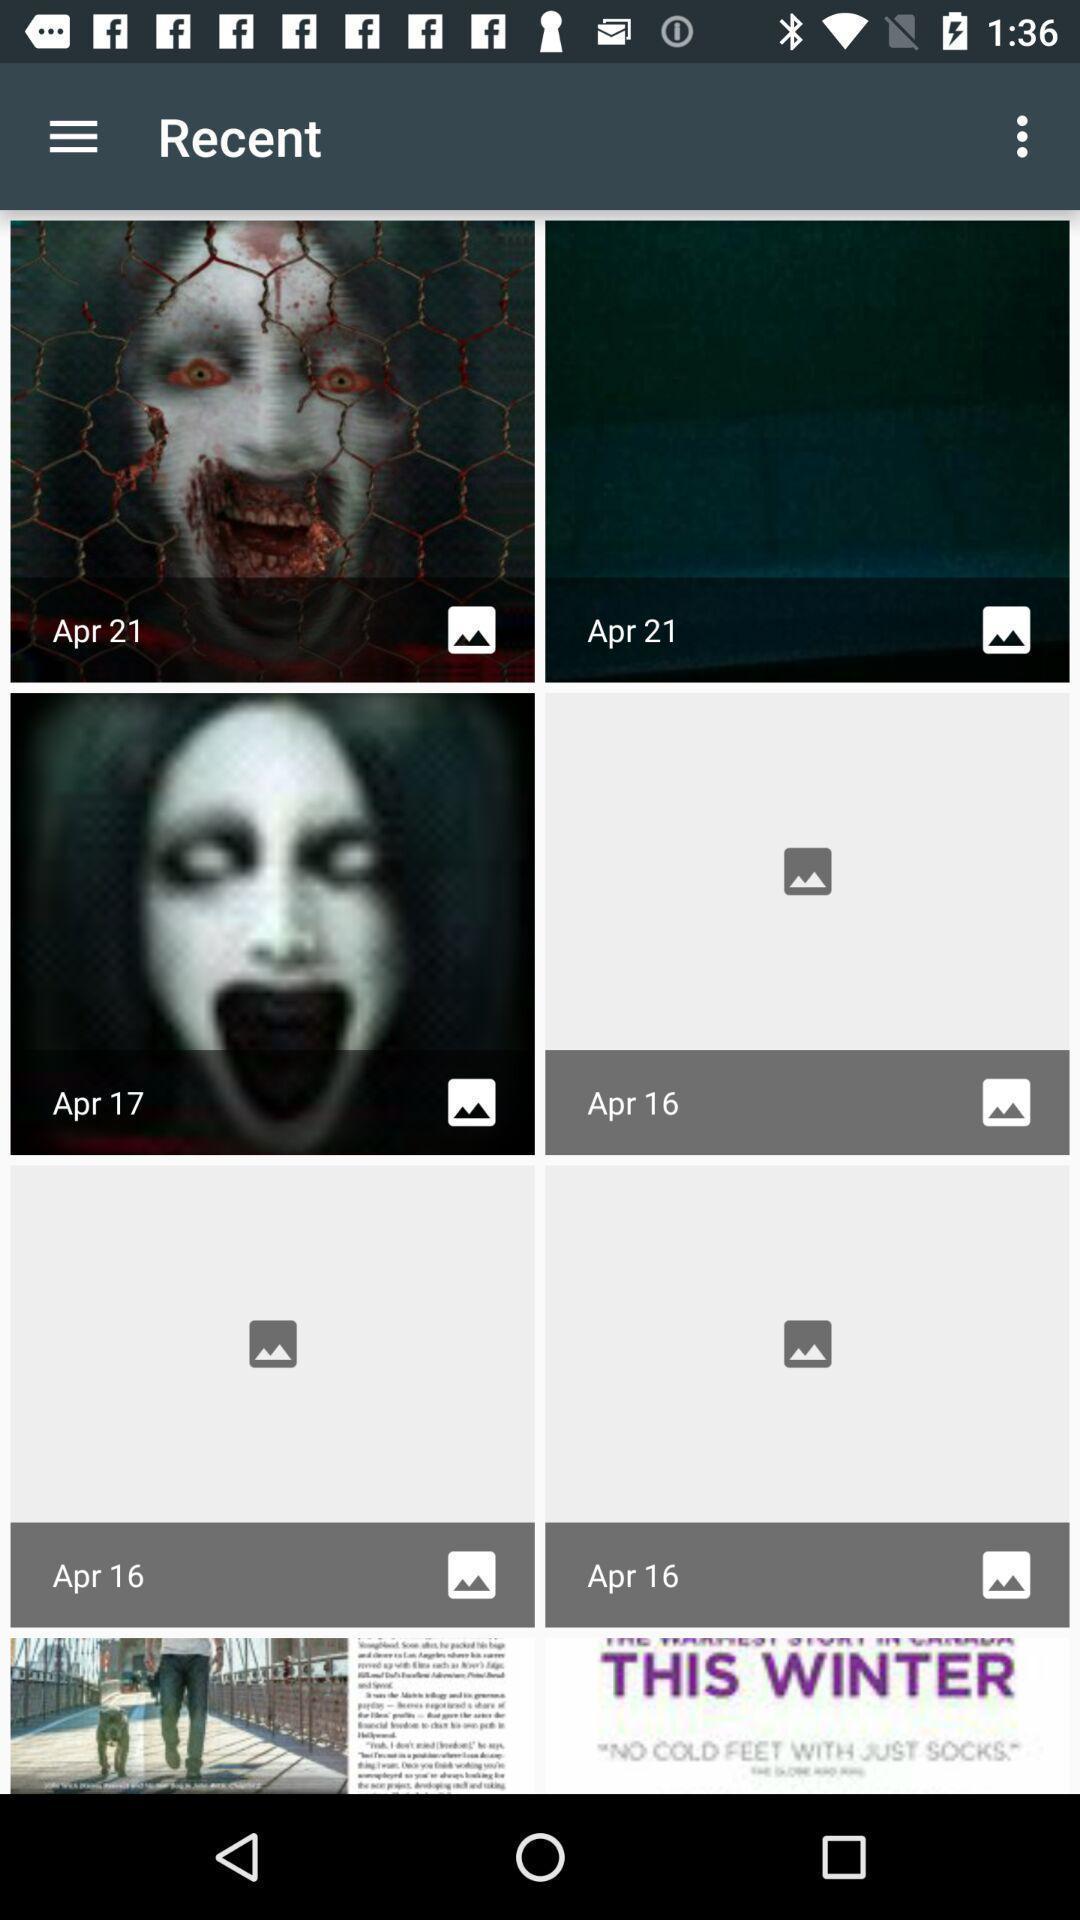Describe the content in this image. Page shows the recent dates with scary images on app. 